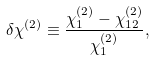Convert formula to latex. <formula><loc_0><loc_0><loc_500><loc_500>\delta \chi ^ { ( 2 ) } \equiv \frac { \chi ^ { ( 2 ) } _ { 1 } - \chi ^ { ( 2 ) } _ { 1 2 } } { \chi ^ { ( 2 ) } _ { 1 } } ,</formula> 